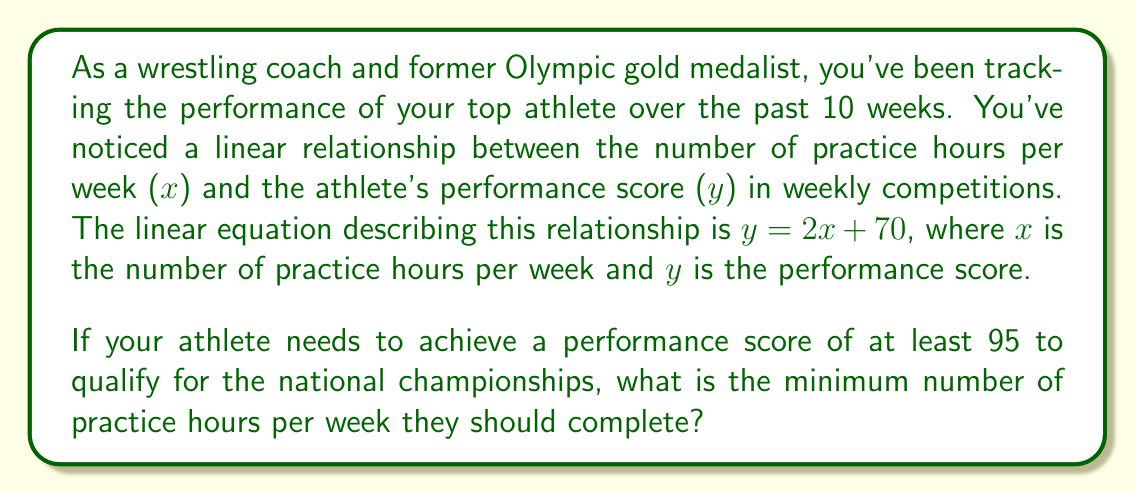Show me your answer to this math problem. To solve this problem, we need to use the given linear equation and find the value of x (practice hours) that corresponds to a y (performance score) of 95 or higher. Let's approach this step-by-step:

1. We're given the linear equation: $y = 2x + 70$

2. We want to find x when y is at least 95. So, we can set up the inequality:
   $95 \leq 2x + 70$

3. Subtract 70 from both sides:
   $25 \leq 2x$

4. Divide both sides by 2:
   $12.5 \leq x$

5. Since we're looking for the minimum number of practice hours, and x represents hours (which can't be fractional in this context), we need to round up to the nearest whole number.

6. Rounding 12.5 up to the nearest whole number gives us 13.

Therefore, the athlete needs to practice for at least 13 hours per week to achieve a performance score of at least 95.

To verify:
If $x = 13$, then $y = 2(13) + 70 = 26 + 70 = 96$, which is indeed greater than or equal to 95.
Answer: The athlete should complete a minimum of 13 practice hours per week. 